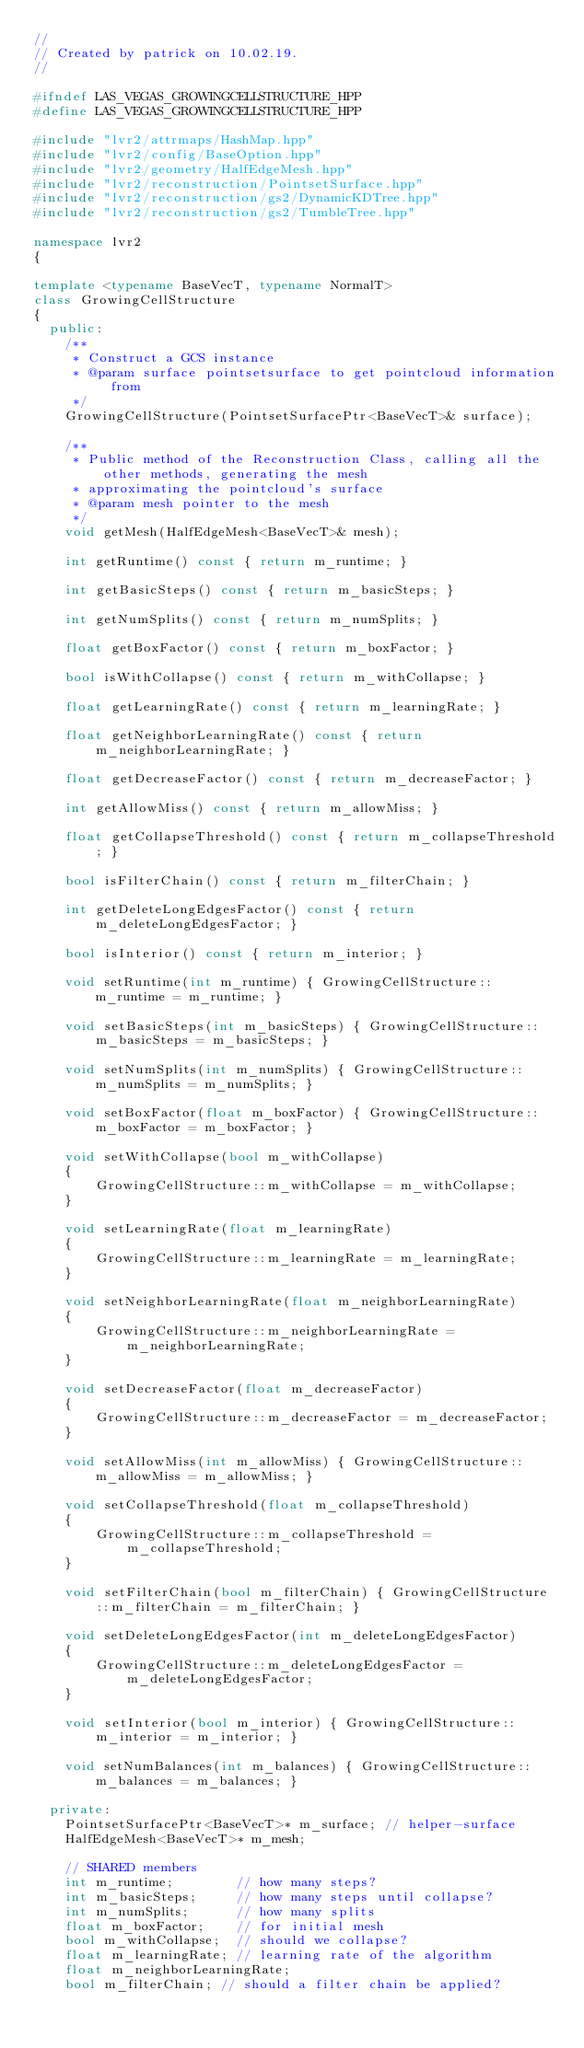Convert code to text. <code><loc_0><loc_0><loc_500><loc_500><_C++_>//
// Created by patrick on 10.02.19.
//

#ifndef LAS_VEGAS_GROWINGCELLSTRUCTURE_HPP
#define LAS_VEGAS_GROWINGCELLSTRUCTURE_HPP

#include "lvr2/attrmaps/HashMap.hpp"
#include "lvr2/config/BaseOption.hpp"
#include "lvr2/geometry/HalfEdgeMesh.hpp"
#include "lvr2/reconstruction/PointsetSurface.hpp"
#include "lvr2/reconstruction/gs2/DynamicKDTree.hpp"
#include "lvr2/reconstruction/gs2/TumbleTree.hpp"

namespace lvr2
{

template <typename BaseVecT, typename NormalT>
class GrowingCellStructure
{
  public:
    /**
     * Construct a GCS instance
     * @param surface pointsetsurface to get pointcloud information from
     */
    GrowingCellStructure(PointsetSurfacePtr<BaseVecT>& surface);

    /**
     * Public method of the Reconstruction Class, calling all the other methods, generating the mesh
     * approximating the pointcloud's surface
     * @param mesh pointer to the mesh
     */
    void getMesh(HalfEdgeMesh<BaseVecT>& mesh);

    int getRuntime() const { return m_runtime; }

    int getBasicSteps() const { return m_basicSteps; }

    int getNumSplits() const { return m_numSplits; }

    float getBoxFactor() const { return m_boxFactor; }

    bool isWithCollapse() const { return m_withCollapse; }

    float getLearningRate() const { return m_learningRate; }

    float getNeighborLearningRate() const { return m_neighborLearningRate; }

    float getDecreaseFactor() const { return m_decreaseFactor; }

    int getAllowMiss() const { return m_allowMiss; }

    float getCollapseThreshold() const { return m_collapseThreshold; }

    bool isFilterChain() const { return m_filterChain; }

    int getDeleteLongEdgesFactor() const { return m_deleteLongEdgesFactor; }

    bool isInterior() const { return m_interior; }

    void setRuntime(int m_runtime) { GrowingCellStructure::m_runtime = m_runtime; }

    void setBasicSteps(int m_basicSteps) { GrowingCellStructure::m_basicSteps = m_basicSteps; }

    void setNumSplits(int m_numSplits) { GrowingCellStructure::m_numSplits = m_numSplits; }

    void setBoxFactor(float m_boxFactor) { GrowingCellStructure::m_boxFactor = m_boxFactor; }

    void setWithCollapse(bool m_withCollapse)
    {
        GrowingCellStructure::m_withCollapse = m_withCollapse;
    }

    void setLearningRate(float m_learningRate)
    {
        GrowingCellStructure::m_learningRate = m_learningRate;
    }

    void setNeighborLearningRate(float m_neighborLearningRate)
    {
        GrowingCellStructure::m_neighborLearningRate = m_neighborLearningRate;
    }

    void setDecreaseFactor(float m_decreaseFactor)
    {
        GrowingCellStructure::m_decreaseFactor = m_decreaseFactor;
    }

    void setAllowMiss(int m_allowMiss) { GrowingCellStructure::m_allowMiss = m_allowMiss; }

    void setCollapseThreshold(float m_collapseThreshold)
    {
        GrowingCellStructure::m_collapseThreshold = m_collapseThreshold;
    }

    void setFilterChain(bool m_filterChain) { GrowingCellStructure::m_filterChain = m_filterChain; }

    void setDeleteLongEdgesFactor(int m_deleteLongEdgesFactor)
    {
        GrowingCellStructure::m_deleteLongEdgesFactor = m_deleteLongEdgesFactor;
    }

    void setInterior(bool m_interior) { GrowingCellStructure::m_interior = m_interior; }

    void setNumBalances(int m_balances) { GrowingCellStructure::m_balances = m_balances; }

  private:
    PointsetSurfacePtr<BaseVecT>* m_surface; // helper-surface
    HalfEdgeMesh<BaseVecT>* m_mesh;

    // SHARED members
    int m_runtime;        // how many steps?
    int m_basicSteps;     // how many steps until collapse?
    int m_numSplits;      // how many splits
    float m_boxFactor;    // for initial mesh
    bool m_withCollapse;  // should we collapse?
    float m_learningRate; // learning rate of the algorithm
    float m_neighborLearningRate;
    bool m_filterChain; // should a filter chain be applied?</code> 